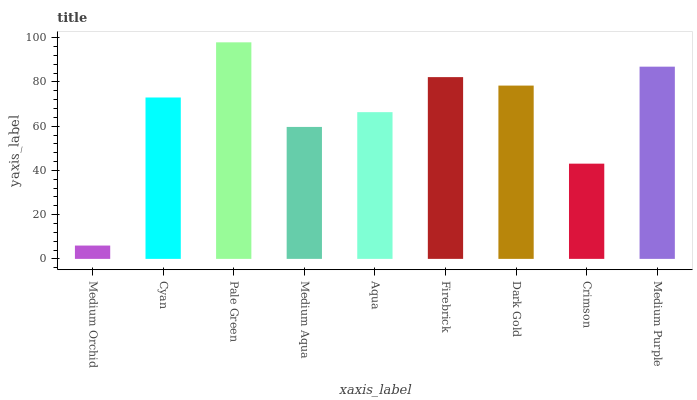Is Medium Orchid the minimum?
Answer yes or no. Yes. Is Pale Green the maximum?
Answer yes or no. Yes. Is Cyan the minimum?
Answer yes or no. No. Is Cyan the maximum?
Answer yes or no. No. Is Cyan greater than Medium Orchid?
Answer yes or no. Yes. Is Medium Orchid less than Cyan?
Answer yes or no. Yes. Is Medium Orchid greater than Cyan?
Answer yes or no. No. Is Cyan less than Medium Orchid?
Answer yes or no. No. Is Cyan the high median?
Answer yes or no. Yes. Is Cyan the low median?
Answer yes or no. Yes. Is Medium Aqua the high median?
Answer yes or no. No. Is Medium Aqua the low median?
Answer yes or no. No. 